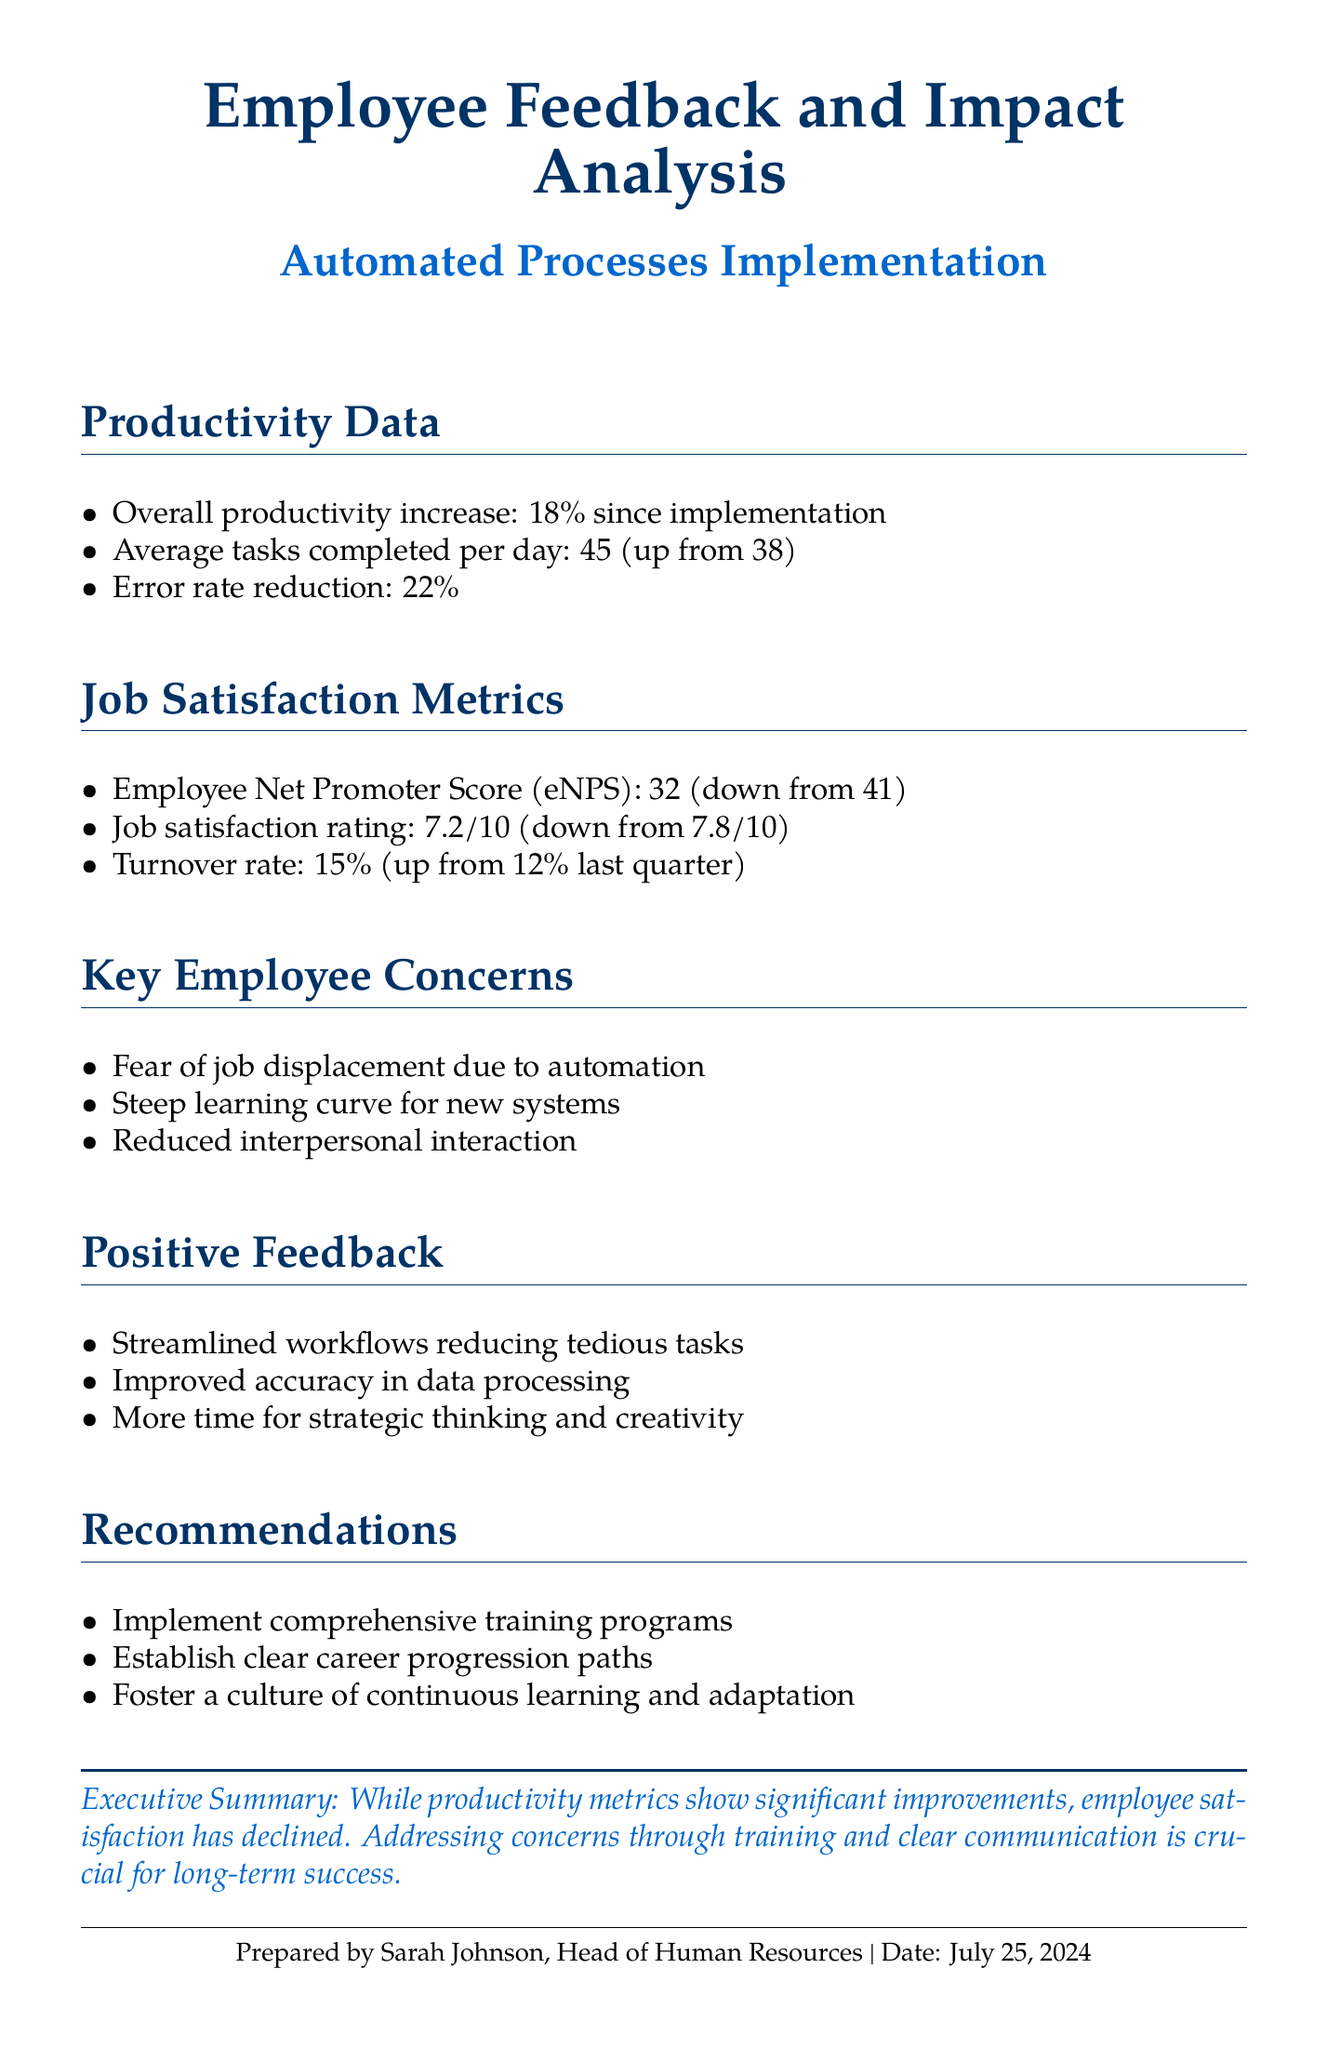What is the percentage increase in overall productivity? The overall productivity increase is clearly stated as 18% since implementation.
Answer: 18% What was the average tasks completed per day before automation? The document states that the average tasks completed per day increased from 38.
Answer: 38 What is the current job satisfaction rating? The job satisfaction rating is mentioned as 7.2 out of 10.
Answer: 7.2/10 What is the current turnover rate? The turnover rate has increased to 15%, as stated in the metrics.
Answer: 15% What key concern relates to the fear of job loss? The specific concern about job displacement due to automation is listed.
Answer: Job displacement How much did the employee Net Promoter Score (eNPS) change? The eNPS has decreased from 41 to 32, indicating a decline.
Answer: 9 points What is a recommended action to address employee concerns? Implementing comprehensive training programs is suggested in the recommendations.
Answer: Training programs What is one aspect of positive feedback regarding the new systems? The document mentions improved accuracy in data processing as positive feedback.
Answer: Improved accuracy What is the primary topic of this document? The document summarizes employee feedback and the impact of automated processes.
Answer: Employee feedback and impact analysis 